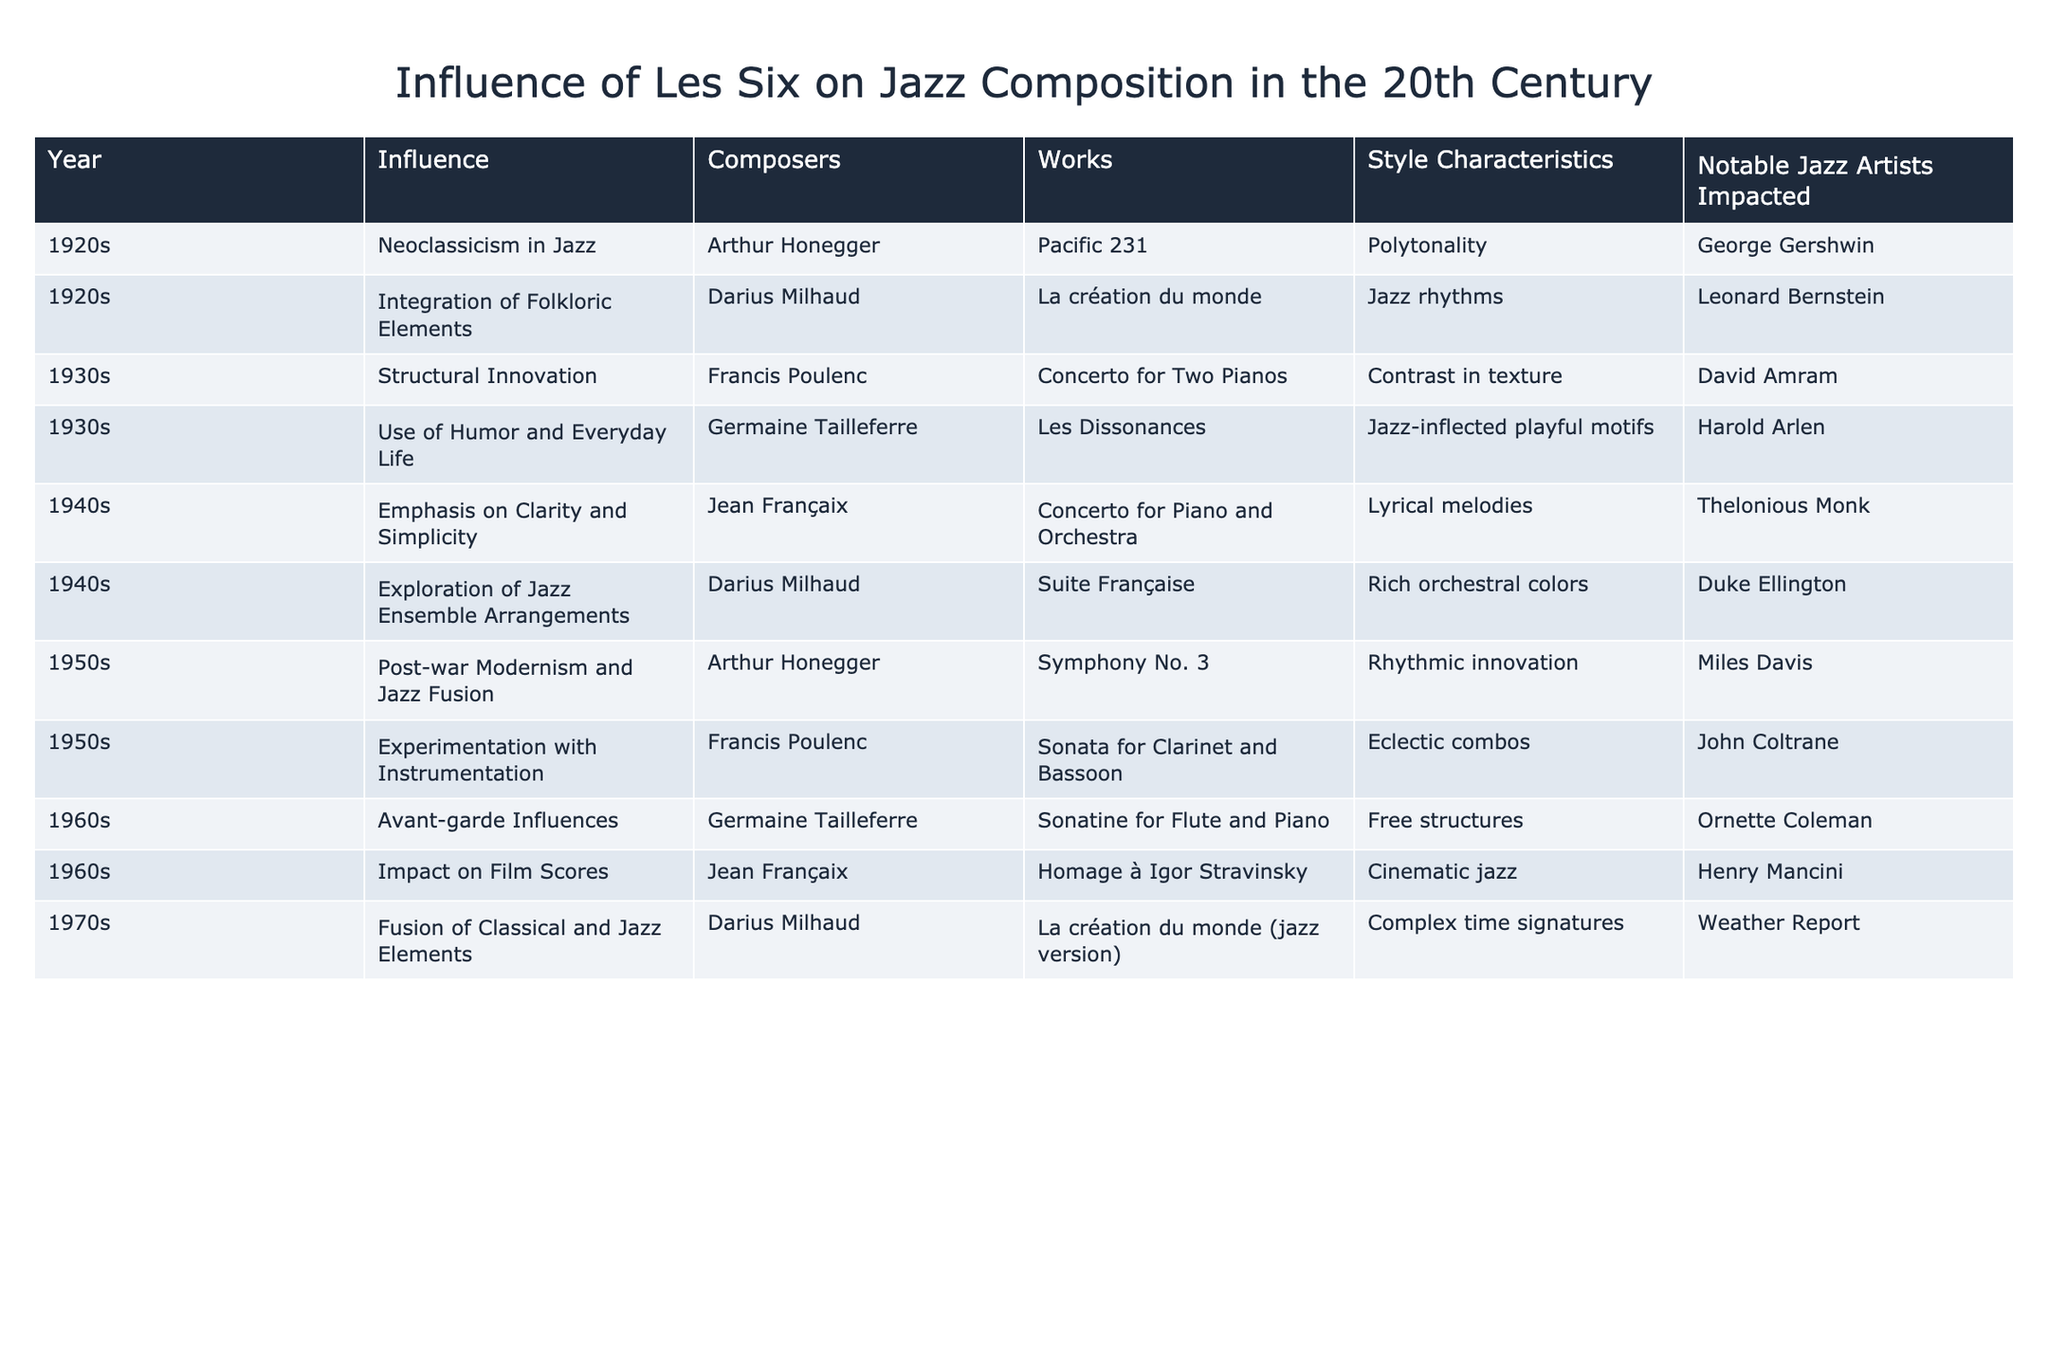What stylistic characteristic is associated with Darius Milhaud's "La création du monde"? According to the table, Darius Milhaud's work "La création du monde" is characterized by "Jazz rhythms."
Answer: Jazz rhythms Which composer had an influence on jazz composition in the 1940s? The table indicates that both Darius Milhaud and Jean Françaix influenced jazz in the 1940s, as they are listed under that decade.
Answer: Darius Milhaud and Jean Françaix How many influential works were created in the 1930s? Looking at the table, there are two works listed in the 1930s: "Concerto for Two Pianos" by Francis Poulenc and "Les Dissonances" by Germaine Tailleferre, so the total is 2.
Answer: 2 Did Arthur Honegger have a notable impact on any jazz artist? Yes, the table states that Arthur Honegger influenced George Gershwin, indicating a notable impact.
Answer: Yes What is the notable jazz artist impacted by Jean Françaix's "Concerto for Piano and Orchestra"? The table lists Thelonious Monk as the notable jazz artist impacted by Jean Françaix's "Concerto for Piano and Orchestra."
Answer: Thelonious Monk What was the average decade listed for the influence of Les Six? The decades mentioned are 1920s, 1930s, 1940s, 1950s, 1960s, and 1970s, which means we sum 1920, 1930, 1940, 1950, 1960, and 1970 to get 11700, divided by 6 to get an average decade of 1950, or more simply just look at the range of decades indicating the period of influence.
Answer: 1950 Which work is associated with the use of humor and everyday life? The table shows that "Les Dissonances" by Germaine Tailleferre is associated with the use of humor and everyday life.
Answer: Les Dissonances What two influences are seen in the 1950s according to the table? According to the table, the influences noted in the 1950s are "Post-war Modernism and Jazz Fusion" and "Experimentation with Instrumentation."
Answer: Post-war Modernism and Jazz Fusion, Experimentation with Instrumentation Which composer’s works were repeated in different styles in the table? Darius Milhaud's "La création du monde" is repeated, with both its original composition listed under the 1920s and a jazz version mentioned in the 1970s.
Answer: Darius Milhaud 